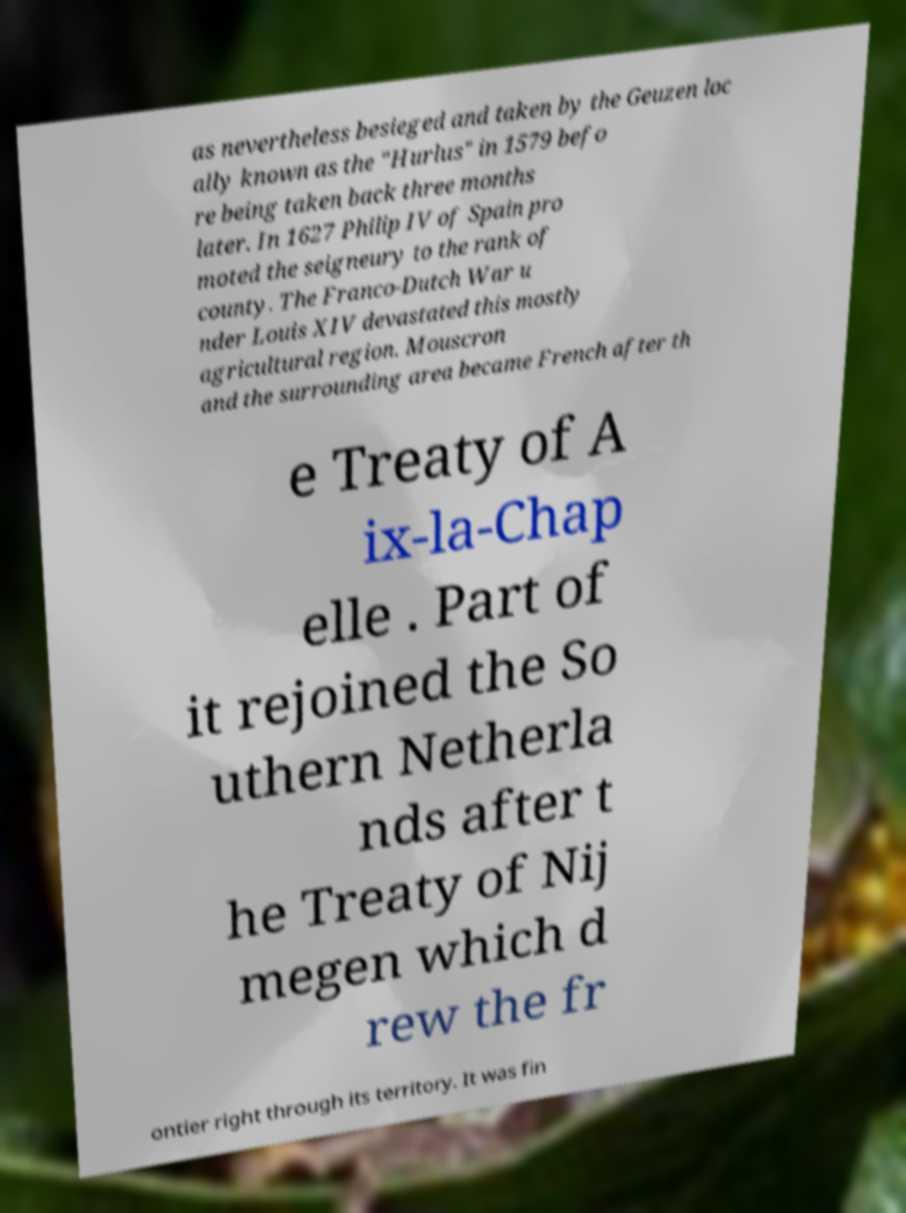Please read and relay the text visible in this image. What does it say? as nevertheless besieged and taken by the Geuzen loc ally known as the "Hurlus" in 1579 befo re being taken back three months later. In 1627 Philip IV of Spain pro moted the seigneury to the rank of county. The Franco-Dutch War u nder Louis XIV devastated this mostly agricultural region. Mouscron and the surrounding area became French after th e Treaty of A ix-la-Chap elle . Part of it rejoined the So uthern Netherla nds after t he Treaty of Nij megen which d rew the fr ontier right through its territory. It was fin 